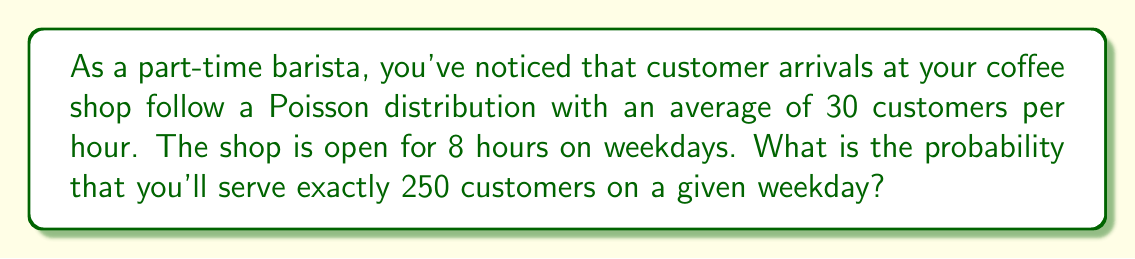Can you solve this math problem? To solve this problem, we need to use the Poisson distribution formula:

$$P(X = k) = \frac{e^{-\lambda} \lambda^k}{k!}$$

Where:
- $\lambda$ is the average number of events in the given time interval
- $k$ is the number of events we're interested in
- $e$ is Euler's number (approximately 2.71828)

Given:
- Average of 30 customers per hour
- Shop is open for 8 hours
- We want the probability of exactly 250 customers in 8 hours

Step 1: Calculate $\lambda$ for the entire 8-hour period
$\lambda = 30 \text{ customers/hour} \times 8 \text{ hours} = 240 \text{ customers}$

Step 2: Apply the Poisson distribution formula
$$P(X = 250) = \frac{e^{-240} 240^{250}}{250!}$$

Step 3: Calculate using a scientific calculator or programming language
$P(X = 250) \approx 0.0256$

This means there's approximately a 2.56% chance of serving exactly 250 customers on a given weekday.

Note: This probability might seem low, but it's because we're asking for exactly 250 customers. In reality, there's a higher probability of serving a number of customers close to 250.
Answer: $P(X = 250) \approx 0.0256$ or 2.56% 